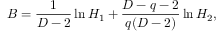<formula> <loc_0><loc_0><loc_500><loc_500>B = \frac { 1 } { D - 2 } \ln H _ { 1 } + \frac { D - q - 2 } { q ( D - 2 ) } \ln H _ { 2 } ,</formula> 